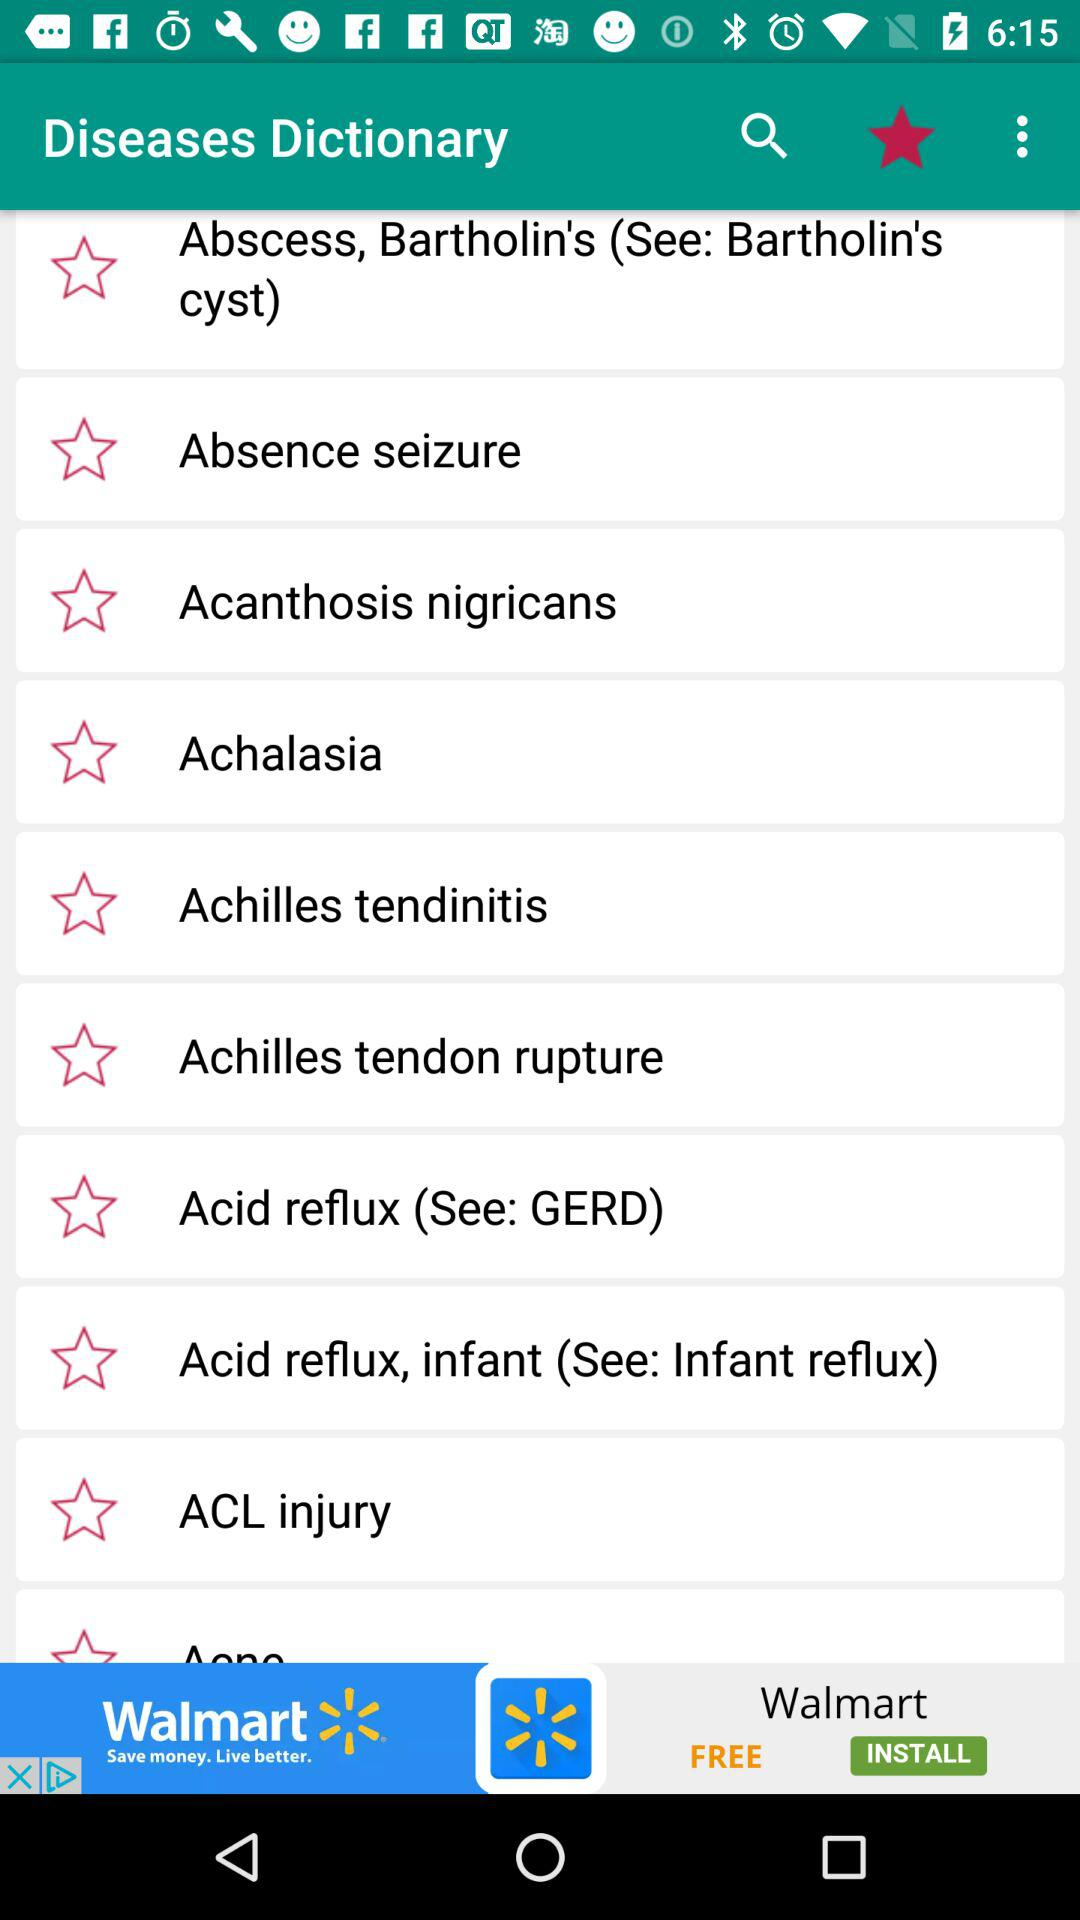Which symptoms does acid reflux produce?
When the provided information is insufficient, respond with <no answer>. <no answer> 